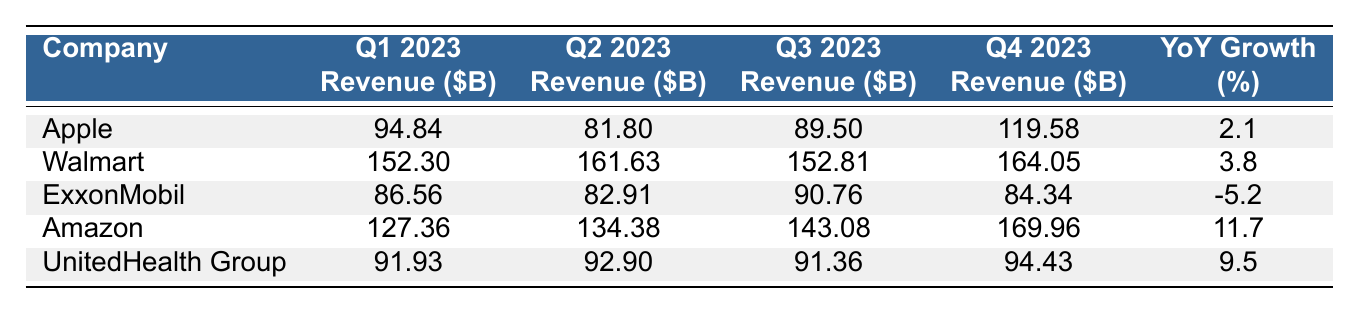What is the revenue of Walmart in Q2 2023? The table shows that Walmart's revenue in Q2 2023 is listed as 161.63 billion dollars.
Answer: 161.63 billion dollars Which company had the highest revenue in Q1 2023? Looking at the Q1 2023 column, Walmart's revenue is the highest at 152.30 billion dollars compared to others in the list.
Answer: Walmart What is the total revenue of Apple for all four quarters? By adding Apple's revenue for each quarter: 94.84 + 81.80 + 89.50 + 119.58 = 385.72 billion dollars.
Answer: 385.72 billion dollars What percentage growth did ExxonMobil experience year-over-year? The table indicates that ExxonMobil had a year-over-year growth of -5.2%, indicating a decrease in revenue compared to the previous year.
Answer: -5.2% Which company had the largest quarter-over-quarter revenue increase from Q3 to Q4 2023? Comparing the Q3 and Q4 revenues, Amazon's revenue increased from 143.08 to 169.96 billion dollars (a difference of 26.88 billion dollars), which is the largest increase among all companies listed.
Answer: Amazon In which quarter did UnitedHealth Group have the lowest revenue? UnitedHealth Group's lowest revenue appears in Q3 2023, recorded at 91.36 billion dollars, which is lower than the other quarters.
Answer: Q3 2023 What is the average revenue of the top 5 companies in Q2 2023? Summing the Q2 revenues: 81.80 + 161.63 + 82.91 + 134.38 + 92.90 = 553.62 billion dollars, and dividing by 5 gives 110.72 billion dollars as the average revenue.
Answer: 110.72 billion dollars Did Amazon experience a higher year-over-year growth rate than Walmart? Amazon's year-over-year growth of 11.7% is significantly higher than Walmart's 3.8%, confirming that Amazon had a better growth rate.
Answer: Yes Which company had the third highest revenue in Q4 2023? In the Q4 2023 column, Apple's revenue at 119.58 billion places it as the third highest after Amazon and Walmart, which had revenues of 169.96 and 164.05 billion, respectively.
Answer: Apple How many companies recorded a negative year-over-year growth percentage? Only ExxonMobil is listed in the table with a negative year-over-year growth rate of -5.2%, indicating it is the only company with a decrease.
Answer: One company 